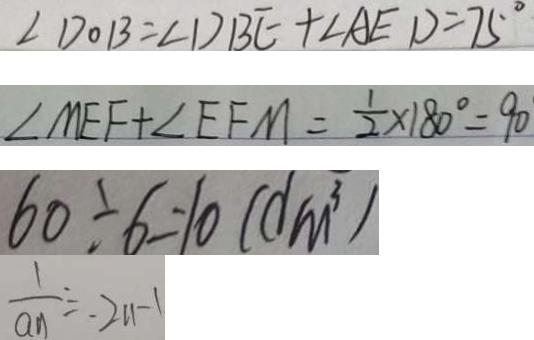<formula> <loc_0><loc_0><loc_500><loc_500>\angle D O B = \angle D B E + \angle A E D = 7 5 ^ { \circ } 
 \angle M E F + \angle E F M = \frac { 1 } { 2 } \times 1 8 0 ^ { \circ } = 9 0 
 6 0 \div 6 = 1 0 ( d m ^ { 3 } ) 
 \frac { 1 } { a _ { n } } = 2 n - 1</formula> 